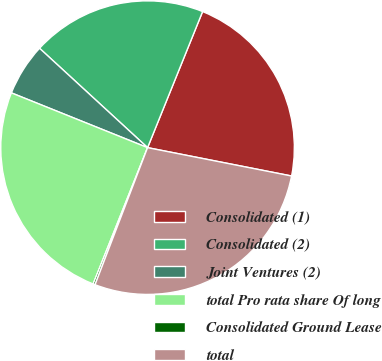Convert chart to OTSL. <chart><loc_0><loc_0><loc_500><loc_500><pie_chart><fcel>Consolidated (1)<fcel>Consolidated (2)<fcel>Joint Ventures (2)<fcel>total Pro rata share Of long<fcel>Consolidated Ground Lease<fcel>total<nl><fcel>21.98%<fcel>19.28%<fcel>5.75%<fcel>25.04%<fcel>0.22%<fcel>27.73%<nl></chart> 